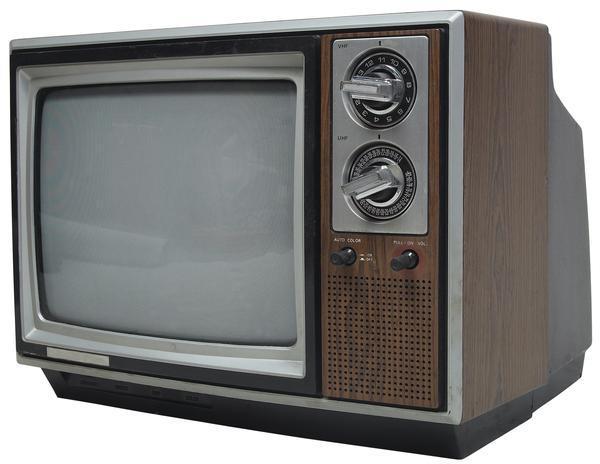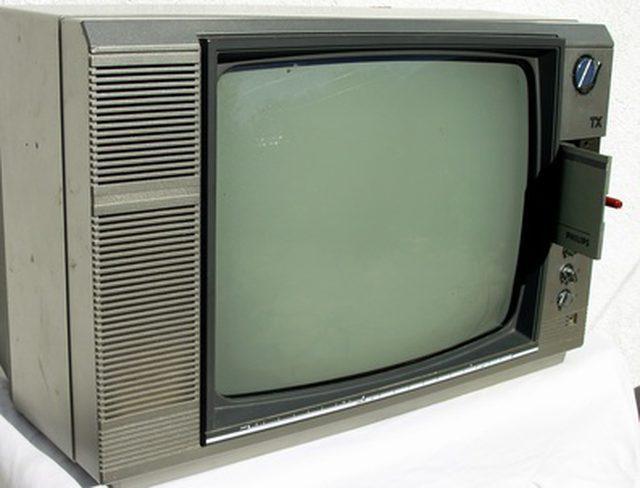The first image is the image on the left, the second image is the image on the right. Evaluate the accuracy of this statement regarding the images: "One image shows an old-fashioned TV set with two large knobs arranged vertically alongside the screen.". Is it true? Answer yes or no. Yes. 